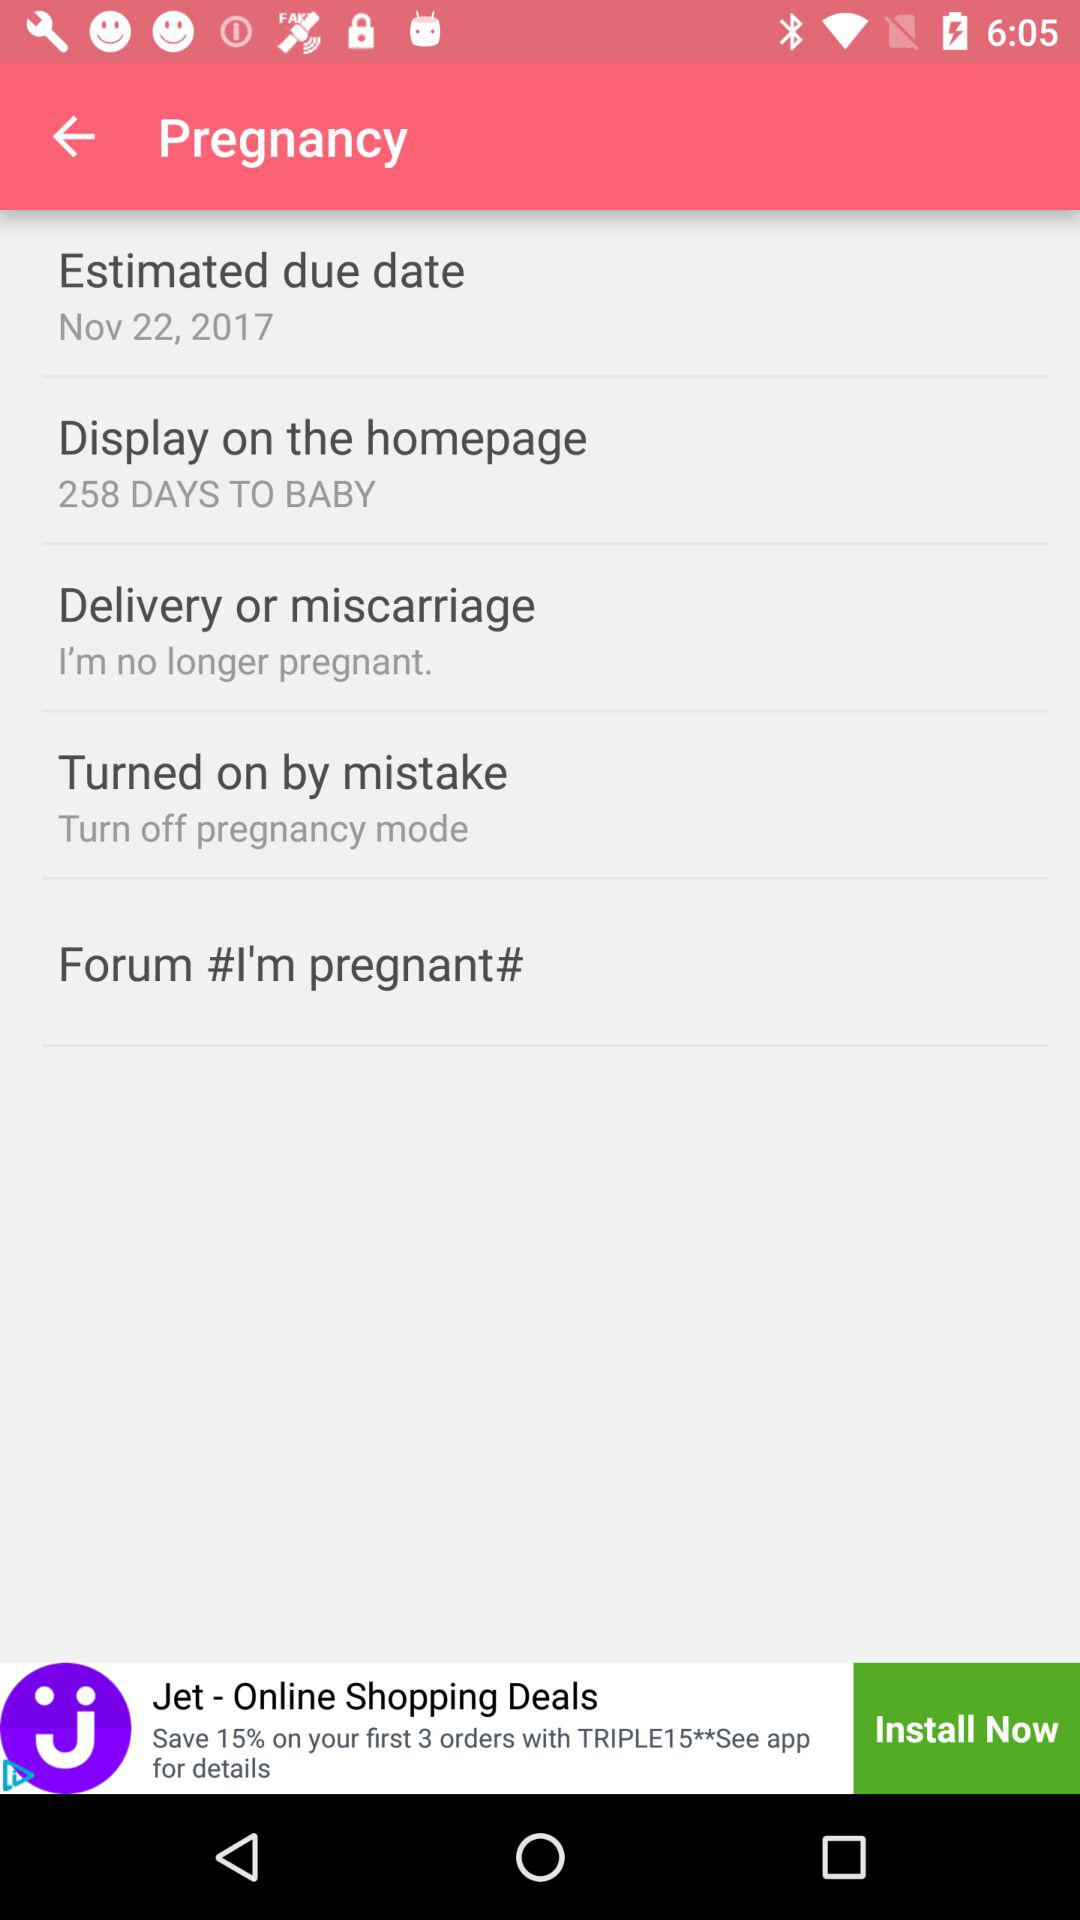How many more days until the estimated due date?
Answer the question using a single word or phrase. 258 